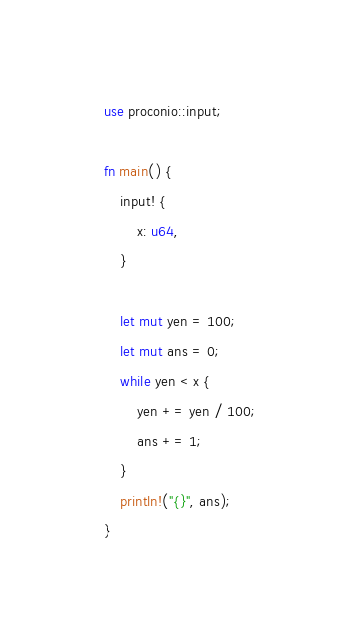<code> <loc_0><loc_0><loc_500><loc_500><_Rust_>use proconio::input;

fn main() {
    input! {
        x: u64,
    }

    let mut yen = 100;
    let mut ans = 0;
    while yen < x {
        yen += yen / 100;
        ans += 1;
    }
    println!("{}", ans);
}
</code> 